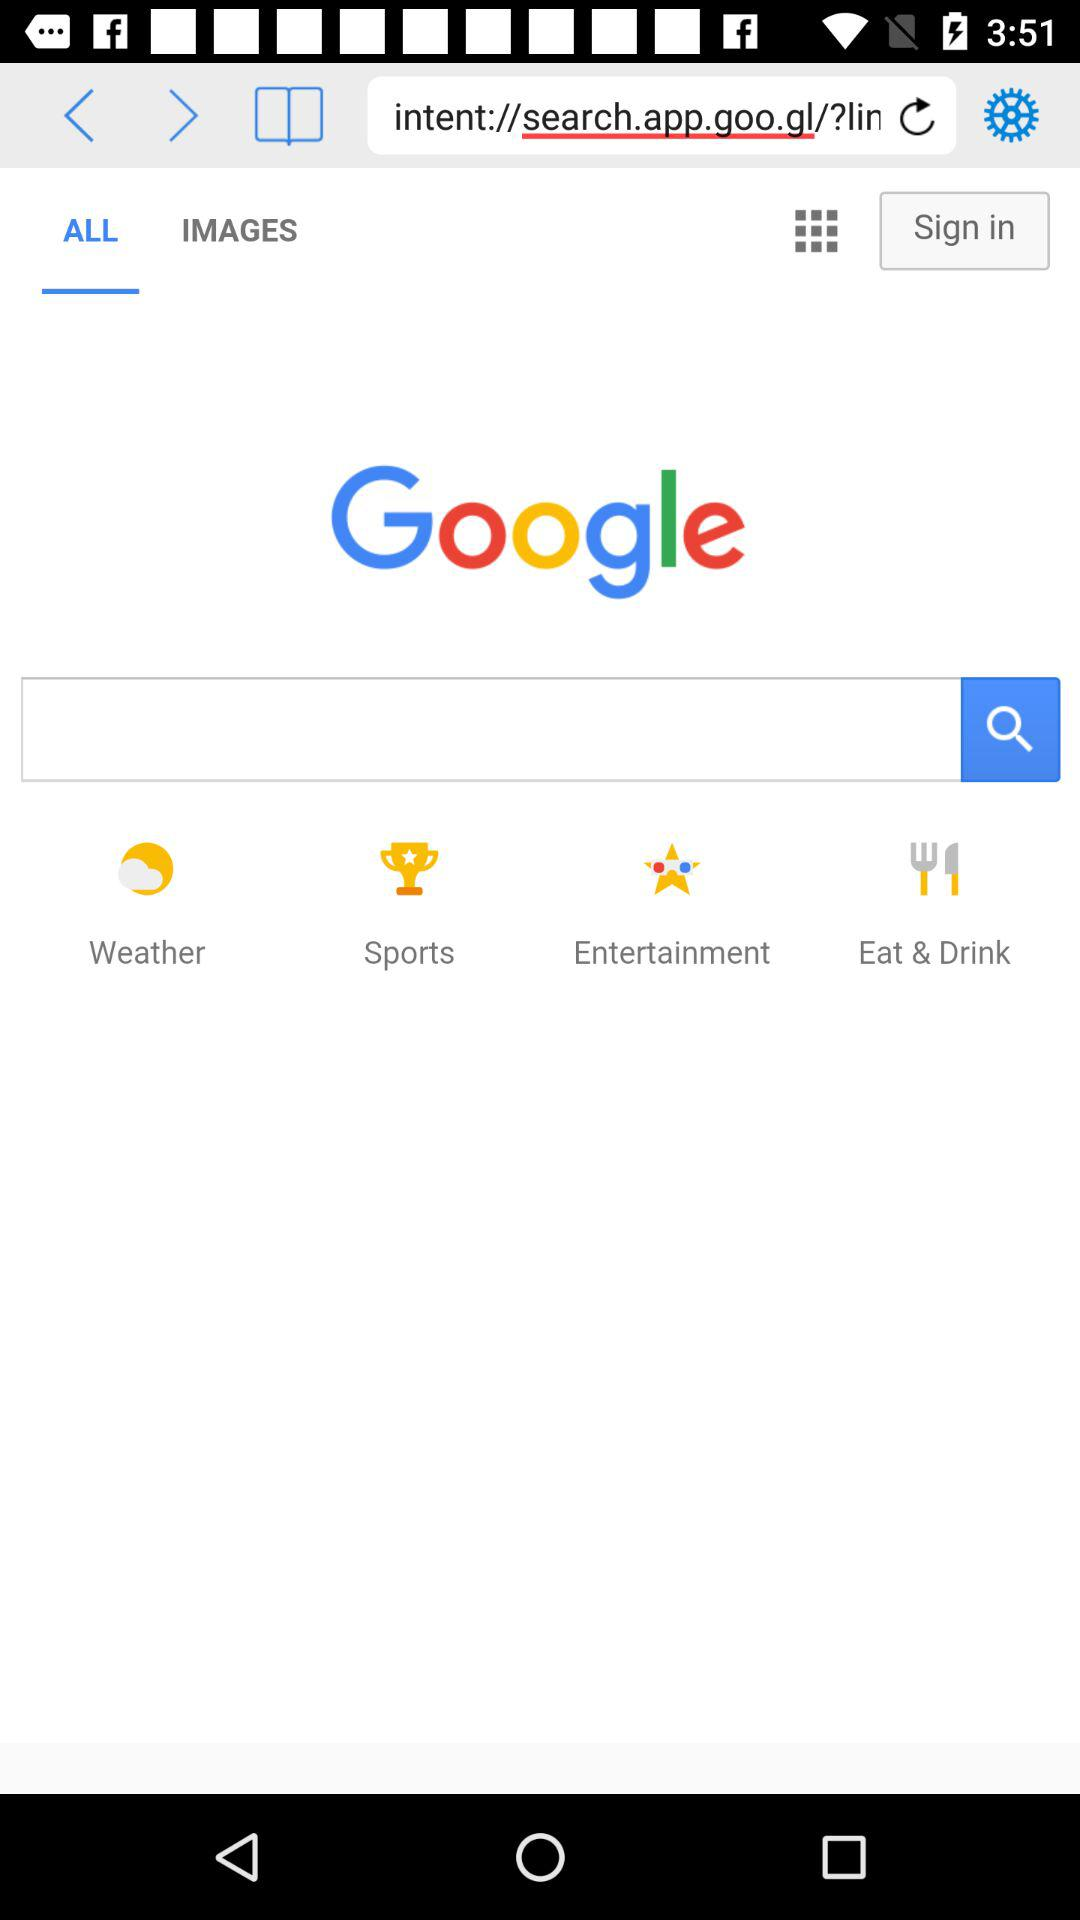What is the selected tab? The selected tab is "ALL". 